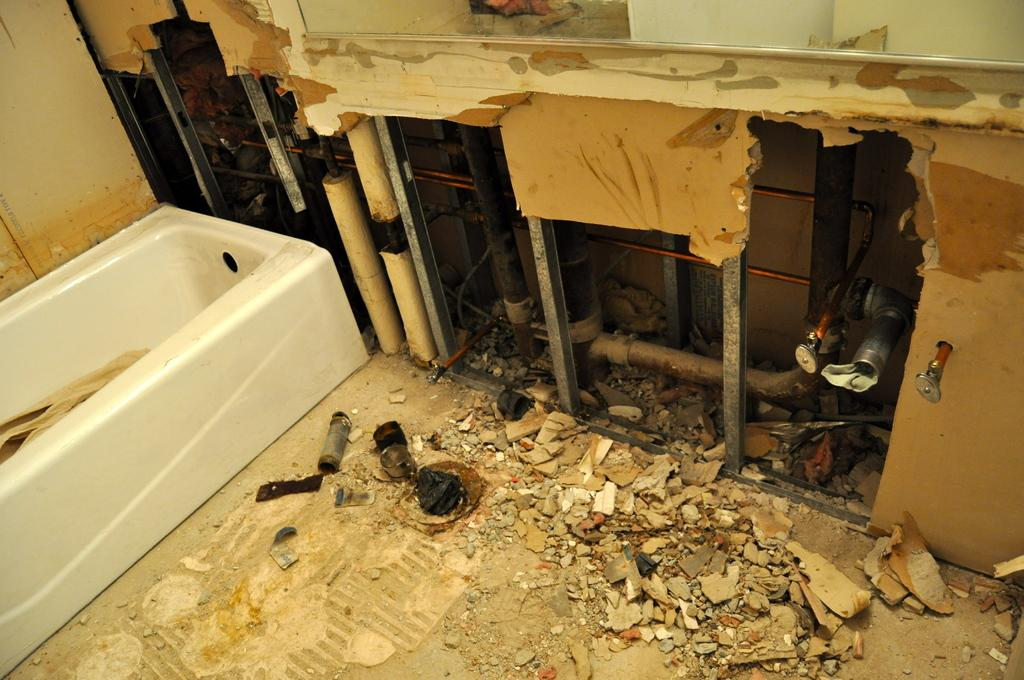What is the main object in the image? There is a bathtub in the image. What other objects can be seen in the image? Grills, pipelines, and stones on the floor are visible in the image. What type of structure is present in the image? Walls are visible in the image. What type of teaching is taking place in the image? There is no teaching activity present in the image. Can you see a mountain in the image? There is no mountain visible in the image. 